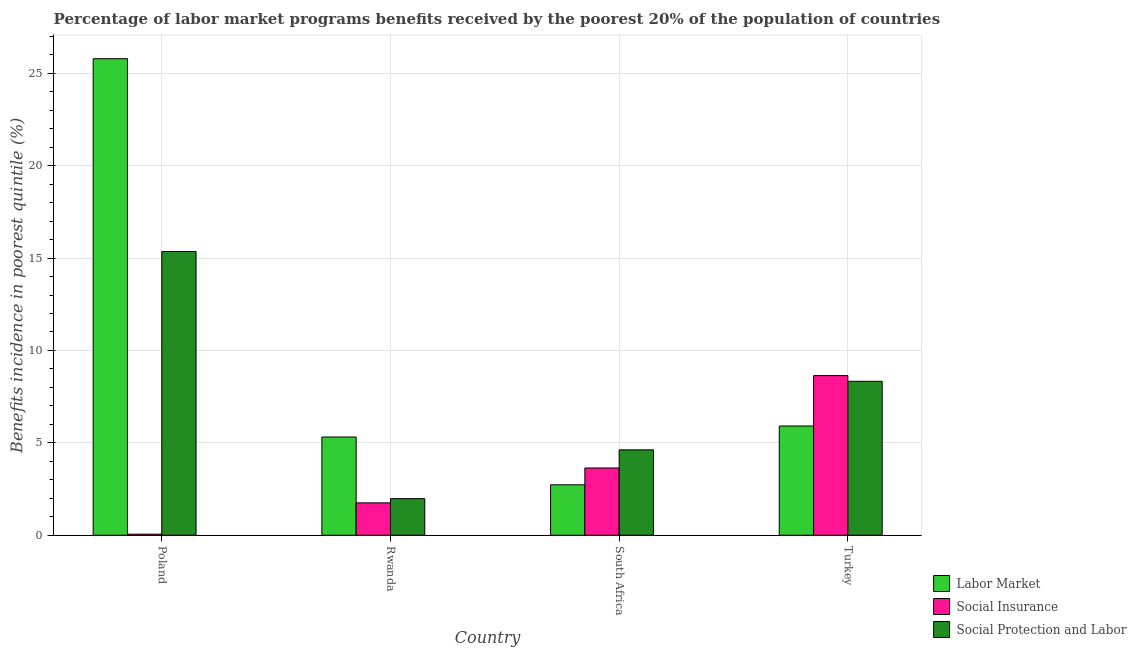How many different coloured bars are there?
Your response must be concise. 3. Are the number of bars per tick equal to the number of legend labels?
Keep it short and to the point. Yes. Are the number of bars on each tick of the X-axis equal?
Provide a short and direct response. Yes. How many bars are there on the 1st tick from the left?
Give a very brief answer. 3. What is the label of the 2nd group of bars from the left?
Make the answer very short. Rwanda. In how many cases, is the number of bars for a given country not equal to the number of legend labels?
Your response must be concise. 0. What is the percentage of benefits received due to social insurance programs in Poland?
Ensure brevity in your answer.  0.06. Across all countries, what is the maximum percentage of benefits received due to social insurance programs?
Offer a terse response. 8.64. Across all countries, what is the minimum percentage of benefits received due to social insurance programs?
Provide a succinct answer. 0.06. In which country was the percentage of benefits received due to labor market programs maximum?
Your answer should be very brief. Poland. In which country was the percentage of benefits received due to labor market programs minimum?
Make the answer very short. South Africa. What is the total percentage of benefits received due to labor market programs in the graph?
Keep it short and to the point. 39.75. What is the difference between the percentage of benefits received due to labor market programs in Rwanda and that in South Africa?
Provide a succinct answer. 2.59. What is the difference between the percentage of benefits received due to labor market programs in Poland and the percentage of benefits received due to social insurance programs in South Africa?
Ensure brevity in your answer.  22.15. What is the average percentage of benefits received due to social insurance programs per country?
Keep it short and to the point. 3.52. What is the difference between the percentage of benefits received due to social insurance programs and percentage of benefits received due to social protection programs in South Africa?
Offer a terse response. -0.98. What is the ratio of the percentage of benefits received due to labor market programs in Poland to that in Rwanda?
Your answer should be compact. 4.85. Is the percentage of benefits received due to social protection programs in South Africa less than that in Turkey?
Your response must be concise. Yes. What is the difference between the highest and the second highest percentage of benefits received due to labor market programs?
Your answer should be very brief. 19.88. What is the difference between the highest and the lowest percentage of benefits received due to social insurance programs?
Offer a very short reply. 8.58. In how many countries, is the percentage of benefits received due to labor market programs greater than the average percentage of benefits received due to labor market programs taken over all countries?
Provide a succinct answer. 1. What does the 2nd bar from the left in Turkey represents?
Your answer should be very brief. Social Insurance. What does the 2nd bar from the right in Poland represents?
Your response must be concise. Social Insurance. What is the difference between two consecutive major ticks on the Y-axis?
Give a very brief answer. 5. Does the graph contain grids?
Keep it short and to the point. Yes. Where does the legend appear in the graph?
Your response must be concise. Bottom right. What is the title of the graph?
Your answer should be compact. Percentage of labor market programs benefits received by the poorest 20% of the population of countries. Does "Taxes on income" appear as one of the legend labels in the graph?
Offer a terse response. No. What is the label or title of the Y-axis?
Your response must be concise. Benefits incidence in poorest quintile (%). What is the Benefits incidence in poorest quintile (%) of Labor Market in Poland?
Provide a short and direct response. 25.79. What is the Benefits incidence in poorest quintile (%) of Social Insurance in Poland?
Provide a short and direct response. 0.06. What is the Benefits incidence in poorest quintile (%) of Social Protection and Labor in Poland?
Offer a very short reply. 15.36. What is the Benefits incidence in poorest quintile (%) in Labor Market in Rwanda?
Offer a very short reply. 5.32. What is the Benefits incidence in poorest quintile (%) of Social Insurance in Rwanda?
Keep it short and to the point. 1.75. What is the Benefits incidence in poorest quintile (%) of Social Protection and Labor in Rwanda?
Ensure brevity in your answer.  1.98. What is the Benefits incidence in poorest quintile (%) in Labor Market in South Africa?
Offer a very short reply. 2.73. What is the Benefits incidence in poorest quintile (%) of Social Insurance in South Africa?
Provide a short and direct response. 3.64. What is the Benefits incidence in poorest quintile (%) in Social Protection and Labor in South Africa?
Your answer should be very brief. 4.62. What is the Benefits incidence in poorest quintile (%) of Labor Market in Turkey?
Ensure brevity in your answer.  5.91. What is the Benefits incidence in poorest quintile (%) of Social Insurance in Turkey?
Provide a succinct answer. 8.64. What is the Benefits incidence in poorest quintile (%) in Social Protection and Labor in Turkey?
Your answer should be compact. 8.33. Across all countries, what is the maximum Benefits incidence in poorest quintile (%) in Labor Market?
Your response must be concise. 25.79. Across all countries, what is the maximum Benefits incidence in poorest quintile (%) in Social Insurance?
Your answer should be very brief. 8.64. Across all countries, what is the maximum Benefits incidence in poorest quintile (%) in Social Protection and Labor?
Offer a very short reply. 15.36. Across all countries, what is the minimum Benefits incidence in poorest quintile (%) in Labor Market?
Offer a very short reply. 2.73. Across all countries, what is the minimum Benefits incidence in poorest quintile (%) in Social Insurance?
Provide a succinct answer. 0.06. Across all countries, what is the minimum Benefits incidence in poorest quintile (%) in Social Protection and Labor?
Provide a succinct answer. 1.98. What is the total Benefits incidence in poorest quintile (%) in Labor Market in the graph?
Provide a short and direct response. 39.75. What is the total Benefits incidence in poorest quintile (%) in Social Insurance in the graph?
Keep it short and to the point. 14.09. What is the total Benefits incidence in poorest quintile (%) in Social Protection and Labor in the graph?
Provide a short and direct response. 30.29. What is the difference between the Benefits incidence in poorest quintile (%) in Labor Market in Poland and that in Rwanda?
Ensure brevity in your answer.  20.47. What is the difference between the Benefits incidence in poorest quintile (%) in Social Insurance in Poland and that in Rwanda?
Offer a very short reply. -1.69. What is the difference between the Benefits incidence in poorest quintile (%) of Social Protection and Labor in Poland and that in Rwanda?
Provide a short and direct response. 13.38. What is the difference between the Benefits incidence in poorest quintile (%) of Labor Market in Poland and that in South Africa?
Give a very brief answer. 23.06. What is the difference between the Benefits incidence in poorest quintile (%) in Social Insurance in Poland and that in South Africa?
Provide a short and direct response. -3.58. What is the difference between the Benefits incidence in poorest quintile (%) in Social Protection and Labor in Poland and that in South Africa?
Your answer should be very brief. 10.73. What is the difference between the Benefits incidence in poorest quintile (%) in Labor Market in Poland and that in Turkey?
Provide a succinct answer. 19.88. What is the difference between the Benefits incidence in poorest quintile (%) in Social Insurance in Poland and that in Turkey?
Provide a succinct answer. -8.58. What is the difference between the Benefits incidence in poorest quintile (%) in Social Protection and Labor in Poland and that in Turkey?
Ensure brevity in your answer.  7.02. What is the difference between the Benefits incidence in poorest quintile (%) of Labor Market in Rwanda and that in South Africa?
Your answer should be very brief. 2.59. What is the difference between the Benefits incidence in poorest quintile (%) in Social Insurance in Rwanda and that in South Africa?
Give a very brief answer. -1.89. What is the difference between the Benefits incidence in poorest quintile (%) in Social Protection and Labor in Rwanda and that in South Africa?
Make the answer very short. -2.64. What is the difference between the Benefits incidence in poorest quintile (%) in Labor Market in Rwanda and that in Turkey?
Provide a short and direct response. -0.6. What is the difference between the Benefits incidence in poorest quintile (%) in Social Insurance in Rwanda and that in Turkey?
Provide a short and direct response. -6.89. What is the difference between the Benefits incidence in poorest quintile (%) in Social Protection and Labor in Rwanda and that in Turkey?
Keep it short and to the point. -6.35. What is the difference between the Benefits incidence in poorest quintile (%) of Labor Market in South Africa and that in Turkey?
Make the answer very short. -3.18. What is the difference between the Benefits incidence in poorest quintile (%) in Social Insurance in South Africa and that in Turkey?
Make the answer very short. -5. What is the difference between the Benefits incidence in poorest quintile (%) in Social Protection and Labor in South Africa and that in Turkey?
Your response must be concise. -3.71. What is the difference between the Benefits incidence in poorest quintile (%) in Labor Market in Poland and the Benefits incidence in poorest quintile (%) in Social Insurance in Rwanda?
Offer a terse response. 24.04. What is the difference between the Benefits incidence in poorest quintile (%) in Labor Market in Poland and the Benefits incidence in poorest quintile (%) in Social Protection and Labor in Rwanda?
Keep it short and to the point. 23.81. What is the difference between the Benefits incidence in poorest quintile (%) of Social Insurance in Poland and the Benefits incidence in poorest quintile (%) of Social Protection and Labor in Rwanda?
Your answer should be compact. -1.92. What is the difference between the Benefits incidence in poorest quintile (%) in Labor Market in Poland and the Benefits incidence in poorest quintile (%) in Social Insurance in South Africa?
Keep it short and to the point. 22.15. What is the difference between the Benefits incidence in poorest quintile (%) of Labor Market in Poland and the Benefits incidence in poorest quintile (%) of Social Protection and Labor in South Africa?
Provide a succinct answer. 21.17. What is the difference between the Benefits incidence in poorest quintile (%) of Social Insurance in Poland and the Benefits incidence in poorest quintile (%) of Social Protection and Labor in South Africa?
Provide a short and direct response. -4.56. What is the difference between the Benefits incidence in poorest quintile (%) in Labor Market in Poland and the Benefits incidence in poorest quintile (%) in Social Insurance in Turkey?
Keep it short and to the point. 17.15. What is the difference between the Benefits incidence in poorest quintile (%) in Labor Market in Poland and the Benefits incidence in poorest quintile (%) in Social Protection and Labor in Turkey?
Provide a short and direct response. 17.46. What is the difference between the Benefits incidence in poorest quintile (%) in Social Insurance in Poland and the Benefits incidence in poorest quintile (%) in Social Protection and Labor in Turkey?
Make the answer very short. -8.27. What is the difference between the Benefits incidence in poorest quintile (%) in Labor Market in Rwanda and the Benefits incidence in poorest quintile (%) in Social Insurance in South Africa?
Give a very brief answer. 1.68. What is the difference between the Benefits incidence in poorest quintile (%) of Labor Market in Rwanda and the Benefits incidence in poorest quintile (%) of Social Protection and Labor in South Africa?
Keep it short and to the point. 0.69. What is the difference between the Benefits incidence in poorest quintile (%) in Social Insurance in Rwanda and the Benefits incidence in poorest quintile (%) in Social Protection and Labor in South Africa?
Provide a short and direct response. -2.87. What is the difference between the Benefits incidence in poorest quintile (%) of Labor Market in Rwanda and the Benefits incidence in poorest quintile (%) of Social Insurance in Turkey?
Offer a terse response. -3.32. What is the difference between the Benefits incidence in poorest quintile (%) in Labor Market in Rwanda and the Benefits incidence in poorest quintile (%) in Social Protection and Labor in Turkey?
Make the answer very short. -3.02. What is the difference between the Benefits incidence in poorest quintile (%) in Social Insurance in Rwanda and the Benefits incidence in poorest quintile (%) in Social Protection and Labor in Turkey?
Your answer should be very brief. -6.58. What is the difference between the Benefits incidence in poorest quintile (%) of Labor Market in South Africa and the Benefits incidence in poorest quintile (%) of Social Insurance in Turkey?
Make the answer very short. -5.91. What is the difference between the Benefits incidence in poorest quintile (%) in Labor Market in South Africa and the Benefits incidence in poorest quintile (%) in Social Protection and Labor in Turkey?
Offer a terse response. -5.6. What is the difference between the Benefits incidence in poorest quintile (%) in Social Insurance in South Africa and the Benefits incidence in poorest quintile (%) in Social Protection and Labor in Turkey?
Your answer should be compact. -4.69. What is the average Benefits incidence in poorest quintile (%) of Labor Market per country?
Keep it short and to the point. 9.94. What is the average Benefits incidence in poorest quintile (%) of Social Insurance per country?
Ensure brevity in your answer.  3.52. What is the average Benefits incidence in poorest quintile (%) in Social Protection and Labor per country?
Your answer should be very brief. 7.57. What is the difference between the Benefits incidence in poorest quintile (%) of Labor Market and Benefits incidence in poorest quintile (%) of Social Insurance in Poland?
Provide a short and direct response. 25.73. What is the difference between the Benefits incidence in poorest quintile (%) of Labor Market and Benefits incidence in poorest quintile (%) of Social Protection and Labor in Poland?
Your answer should be very brief. 10.43. What is the difference between the Benefits incidence in poorest quintile (%) of Social Insurance and Benefits incidence in poorest quintile (%) of Social Protection and Labor in Poland?
Your response must be concise. -15.3. What is the difference between the Benefits incidence in poorest quintile (%) of Labor Market and Benefits incidence in poorest quintile (%) of Social Insurance in Rwanda?
Keep it short and to the point. 3.56. What is the difference between the Benefits incidence in poorest quintile (%) of Labor Market and Benefits incidence in poorest quintile (%) of Social Protection and Labor in Rwanda?
Your response must be concise. 3.34. What is the difference between the Benefits incidence in poorest quintile (%) in Social Insurance and Benefits incidence in poorest quintile (%) in Social Protection and Labor in Rwanda?
Offer a terse response. -0.23. What is the difference between the Benefits incidence in poorest quintile (%) of Labor Market and Benefits incidence in poorest quintile (%) of Social Insurance in South Africa?
Your response must be concise. -0.91. What is the difference between the Benefits incidence in poorest quintile (%) of Labor Market and Benefits incidence in poorest quintile (%) of Social Protection and Labor in South Africa?
Offer a very short reply. -1.89. What is the difference between the Benefits incidence in poorest quintile (%) in Social Insurance and Benefits incidence in poorest quintile (%) in Social Protection and Labor in South Africa?
Provide a succinct answer. -0.98. What is the difference between the Benefits incidence in poorest quintile (%) in Labor Market and Benefits incidence in poorest quintile (%) in Social Insurance in Turkey?
Ensure brevity in your answer.  -2.73. What is the difference between the Benefits incidence in poorest quintile (%) of Labor Market and Benefits incidence in poorest quintile (%) of Social Protection and Labor in Turkey?
Your answer should be compact. -2.42. What is the difference between the Benefits incidence in poorest quintile (%) in Social Insurance and Benefits incidence in poorest quintile (%) in Social Protection and Labor in Turkey?
Your response must be concise. 0.31. What is the ratio of the Benefits incidence in poorest quintile (%) of Labor Market in Poland to that in Rwanda?
Your answer should be compact. 4.85. What is the ratio of the Benefits incidence in poorest quintile (%) of Social Insurance in Poland to that in Rwanda?
Give a very brief answer. 0.03. What is the ratio of the Benefits incidence in poorest quintile (%) in Social Protection and Labor in Poland to that in Rwanda?
Ensure brevity in your answer.  7.75. What is the ratio of the Benefits incidence in poorest quintile (%) in Labor Market in Poland to that in South Africa?
Give a very brief answer. 9.45. What is the ratio of the Benefits incidence in poorest quintile (%) in Social Insurance in Poland to that in South Africa?
Provide a short and direct response. 0.02. What is the ratio of the Benefits incidence in poorest quintile (%) in Social Protection and Labor in Poland to that in South Africa?
Your answer should be compact. 3.32. What is the ratio of the Benefits incidence in poorest quintile (%) of Labor Market in Poland to that in Turkey?
Give a very brief answer. 4.36. What is the ratio of the Benefits incidence in poorest quintile (%) of Social Insurance in Poland to that in Turkey?
Provide a short and direct response. 0.01. What is the ratio of the Benefits incidence in poorest quintile (%) of Social Protection and Labor in Poland to that in Turkey?
Your answer should be compact. 1.84. What is the ratio of the Benefits incidence in poorest quintile (%) of Labor Market in Rwanda to that in South Africa?
Offer a terse response. 1.95. What is the ratio of the Benefits incidence in poorest quintile (%) of Social Insurance in Rwanda to that in South Africa?
Keep it short and to the point. 0.48. What is the ratio of the Benefits incidence in poorest quintile (%) in Social Protection and Labor in Rwanda to that in South Africa?
Give a very brief answer. 0.43. What is the ratio of the Benefits incidence in poorest quintile (%) in Labor Market in Rwanda to that in Turkey?
Ensure brevity in your answer.  0.9. What is the ratio of the Benefits incidence in poorest quintile (%) of Social Insurance in Rwanda to that in Turkey?
Offer a terse response. 0.2. What is the ratio of the Benefits incidence in poorest quintile (%) of Social Protection and Labor in Rwanda to that in Turkey?
Provide a succinct answer. 0.24. What is the ratio of the Benefits incidence in poorest quintile (%) of Labor Market in South Africa to that in Turkey?
Your response must be concise. 0.46. What is the ratio of the Benefits incidence in poorest quintile (%) in Social Insurance in South Africa to that in Turkey?
Provide a short and direct response. 0.42. What is the ratio of the Benefits incidence in poorest quintile (%) of Social Protection and Labor in South Africa to that in Turkey?
Give a very brief answer. 0.55. What is the difference between the highest and the second highest Benefits incidence in poorest quintile (%) of Labor Market?
Provide a short and direct response. 19.88. What is the difference between the highest and the second highest Benefits incidence in poorest quintile (%) of Social Insurance?
Provide a short and direct response. 5. What is the difference between the highest and the second highest Benefits incidence in poorest quintile (%) of Social Protection and Labor?
Your response must be concise. 7.02. What is the difference between the highest and the lowest Benefits incidence in poorest quintile (%) in Labor Market?
Your response must be concise. 23.06. What is the difference between the highest and the lowest Benefits incidence in poorest quintile (%) in Social Insurance?
Provide a short and direct response. 8.58. What is the difference between the highest and the lowest Benefits incidence in poorest quintile (%) of Social Protection and Labor?
Ensure brevity in your answer.  13.38. 